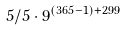Convert formula to latex. <formula><loc_0><loc_0><loc_500><loc_500>5 / 5 \cdot 9 ^ { ( 3 6 5 - 1 ) + 2 9 9 }</formula> 